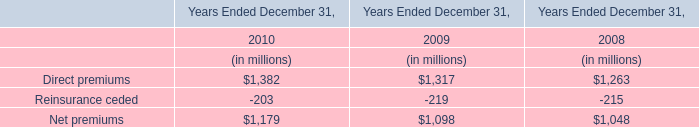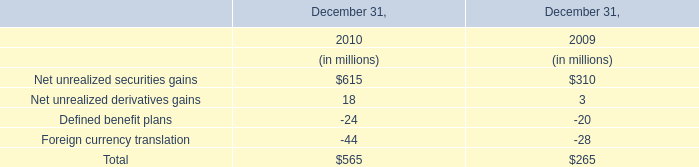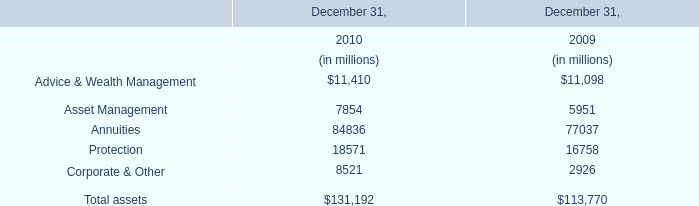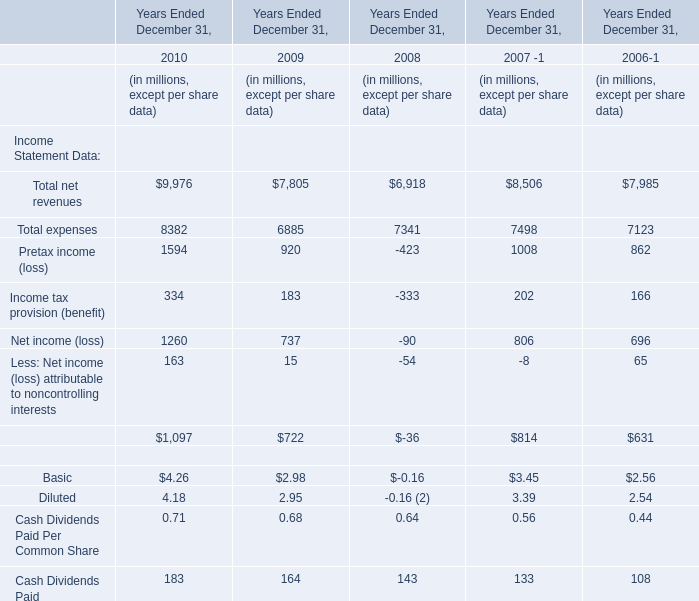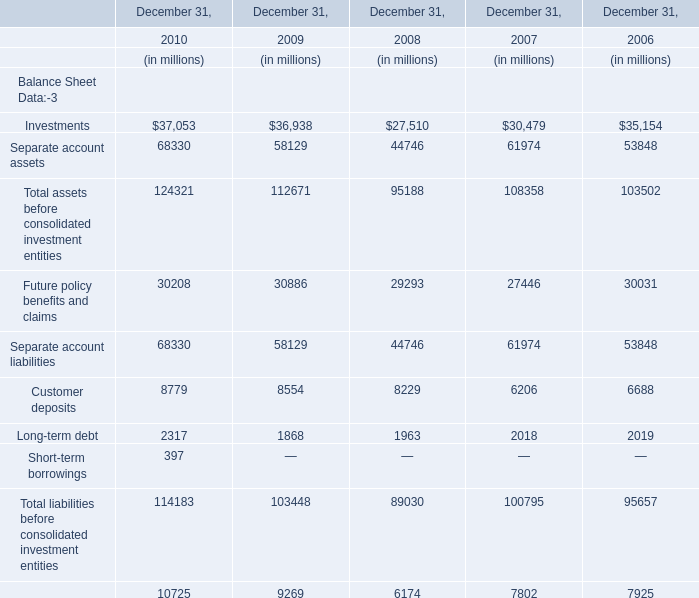In the year with the most Investments, what is the growth rate of eparate account assets? (in %) 
Computations: ((68330 - 58129) / 58129)
Answer: 0.17549. 